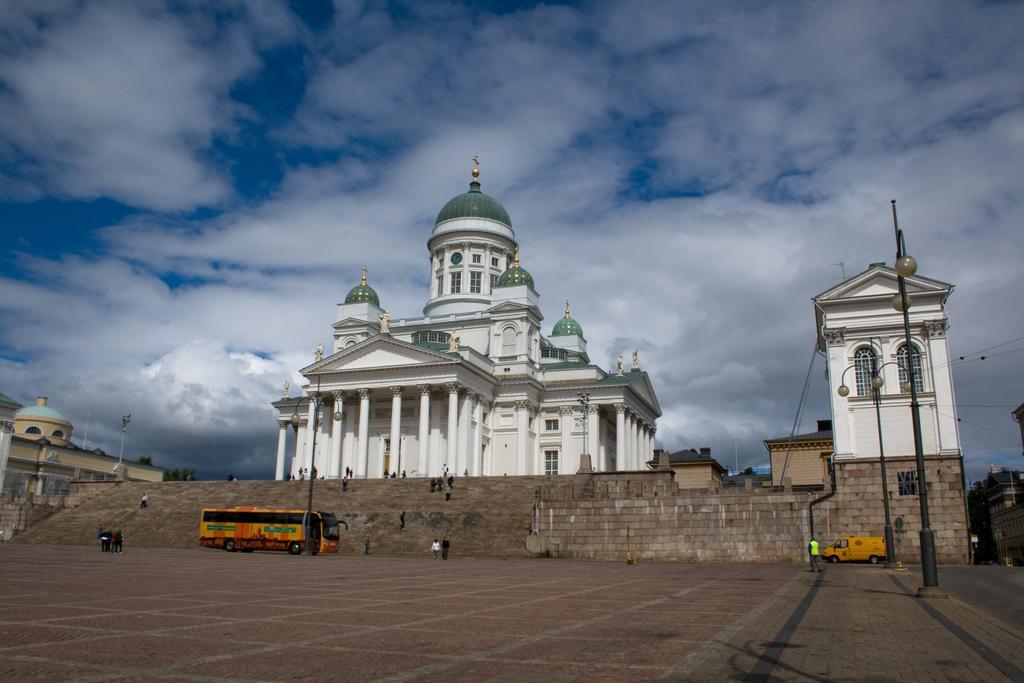Please provide a concise description of this image. In this image I can see few buildings, windows, light poles, stairs, wall, wires and few people around. I can see the sky and few vehicles on the road. 